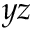<formula> <loc_0><loc_0><loc_500><loc_500>y z</formula> 